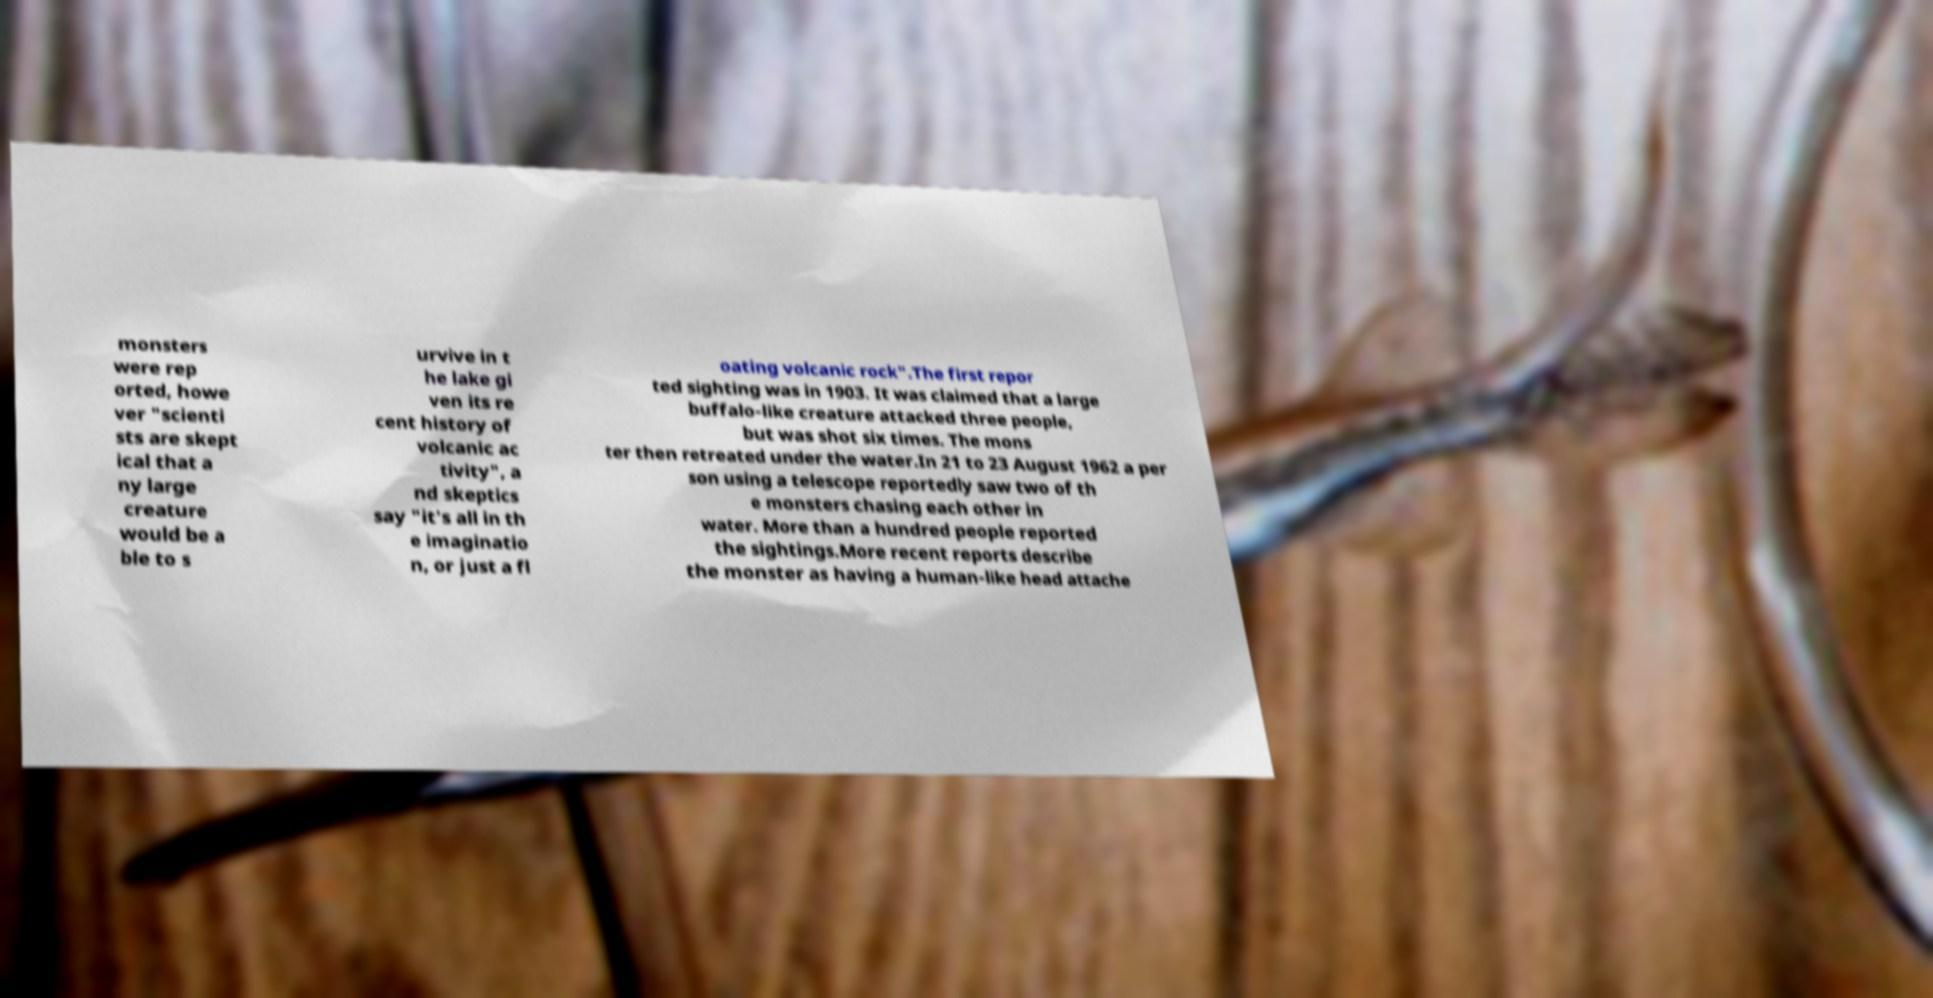There's text embedded in this image that I need extracted. Can you transcribe it verbatim? monsters were rep orted, howe ver "scienti sts are skept ical that a ny large creature would be a ble to s urvive in t he lake gi ven its re cent history of volcanic ac tivity", a nd skeptics say "it's all in th e imaginatio n, or just a fl oating volcanic rock".The first repor ted sighting was in 1903. It was claimed that a large buffalo-like creature attacked three people, but was shot six times. The mons ter then retreated under the water.In 21 to 23 August 1962 a per son using a telescope reportedly saw two of th e monsters chasing each other in water. More than a hundred people reported the sightings.More recent reports describe the monster as having a human-like head attache 